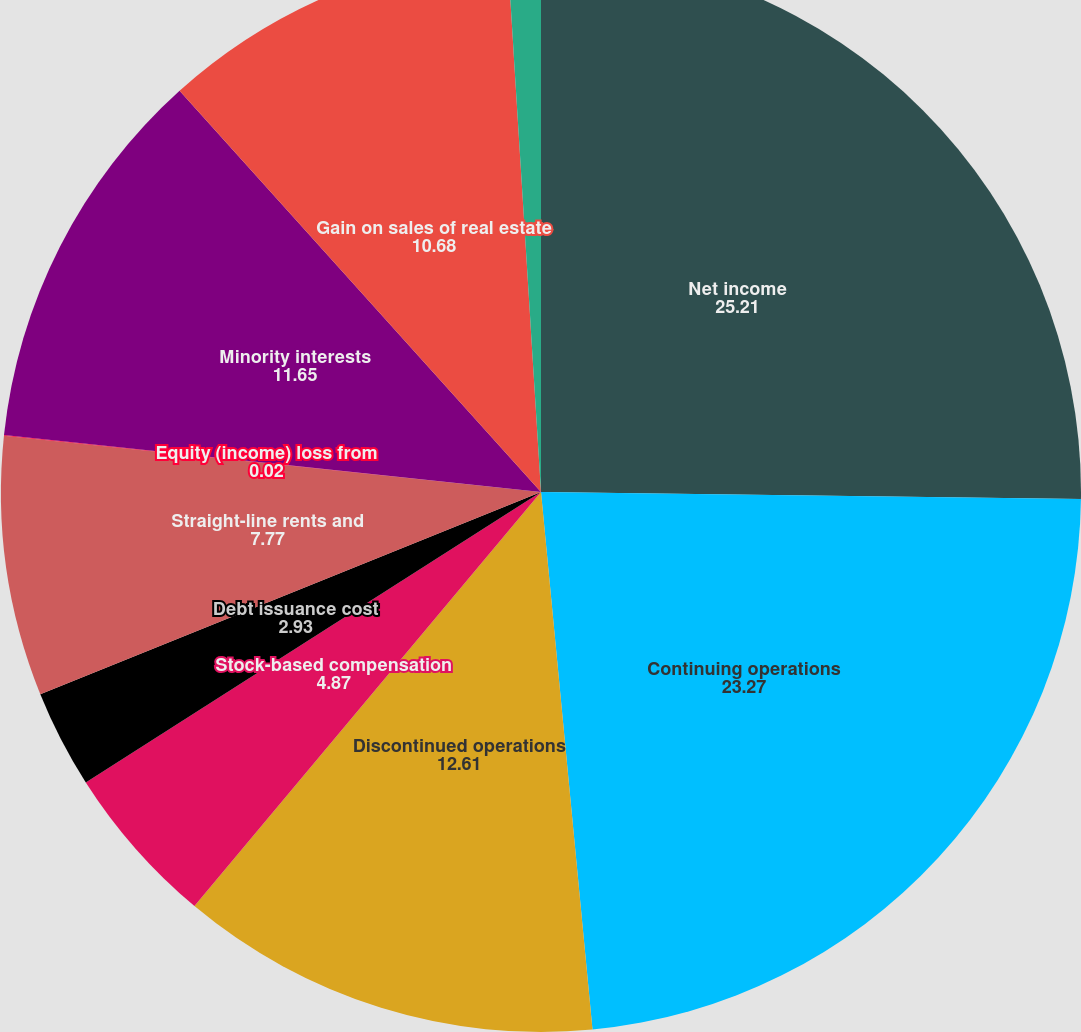Convert chart to OTSL. <chart><loc_0><loc_0><loc_500><loc_500><pie_chart><fcel>Net income<fcel>Continuing operations<fcel>Discontinued operations<fcel>Stock-based compensation<fcel>Debt issuance cost<fcel>Straight-line rents and<fcel>Equity (income) loss from<fcel>Minority interests<fcel>Gain on sales of real estate<fcel>Accounts receivable<nl><fcel>25.21%<fcel>23.27%<fcel>12.61%<fcel>4.87%<fcel>2.93%<fcel>7.77%<fcel>0.02%<fcel>11.65%<fcel>10.68%<fcel>0.99%<nl></chart> 